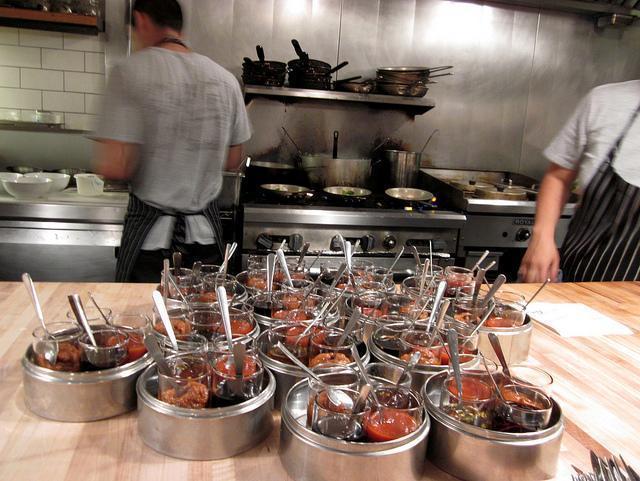Inside silver round large cans what is seen here in profusion?
Select the correct answer and articulate reasoning with the following format: 'Answer: answer
Rationale: rationale.'
Options: Meats, condiments, main dish, side dish. Answer: condiments.
Rationale: A lot of ketchup and soy sauce and hoisin is in the jars. 